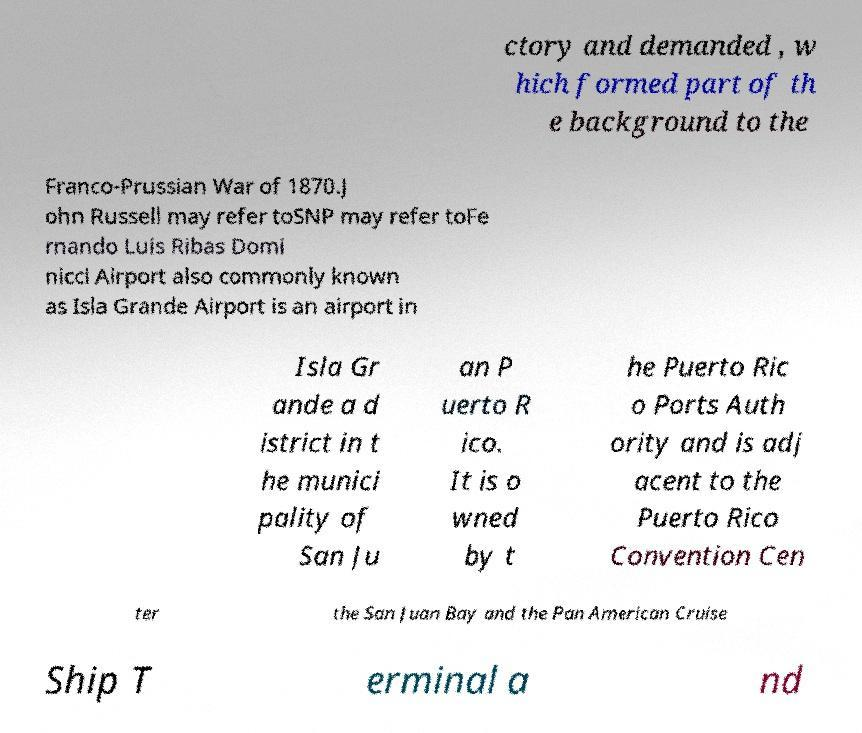Can you accurately transcribe the text from the provided image for me? ctory and demanded , w hich formed part of th e background to the Franco-Prussian War of 1870.J ohn Russell may refer toSNP may refer toFe rnando Luis Ribas Domi nicci Airport also commonly known as Isla Grande Airport is an airport in Isla Gr ande a d istrict in t he munici pality of San Ju an P uerto R ico. It is o wned by t he Puerto Ric o Ports Auth ority and is adj acent to the Puerto Rico Convention Cen ter the San Juan Bay and the Pan American Cruise Ship T erminal a nd 